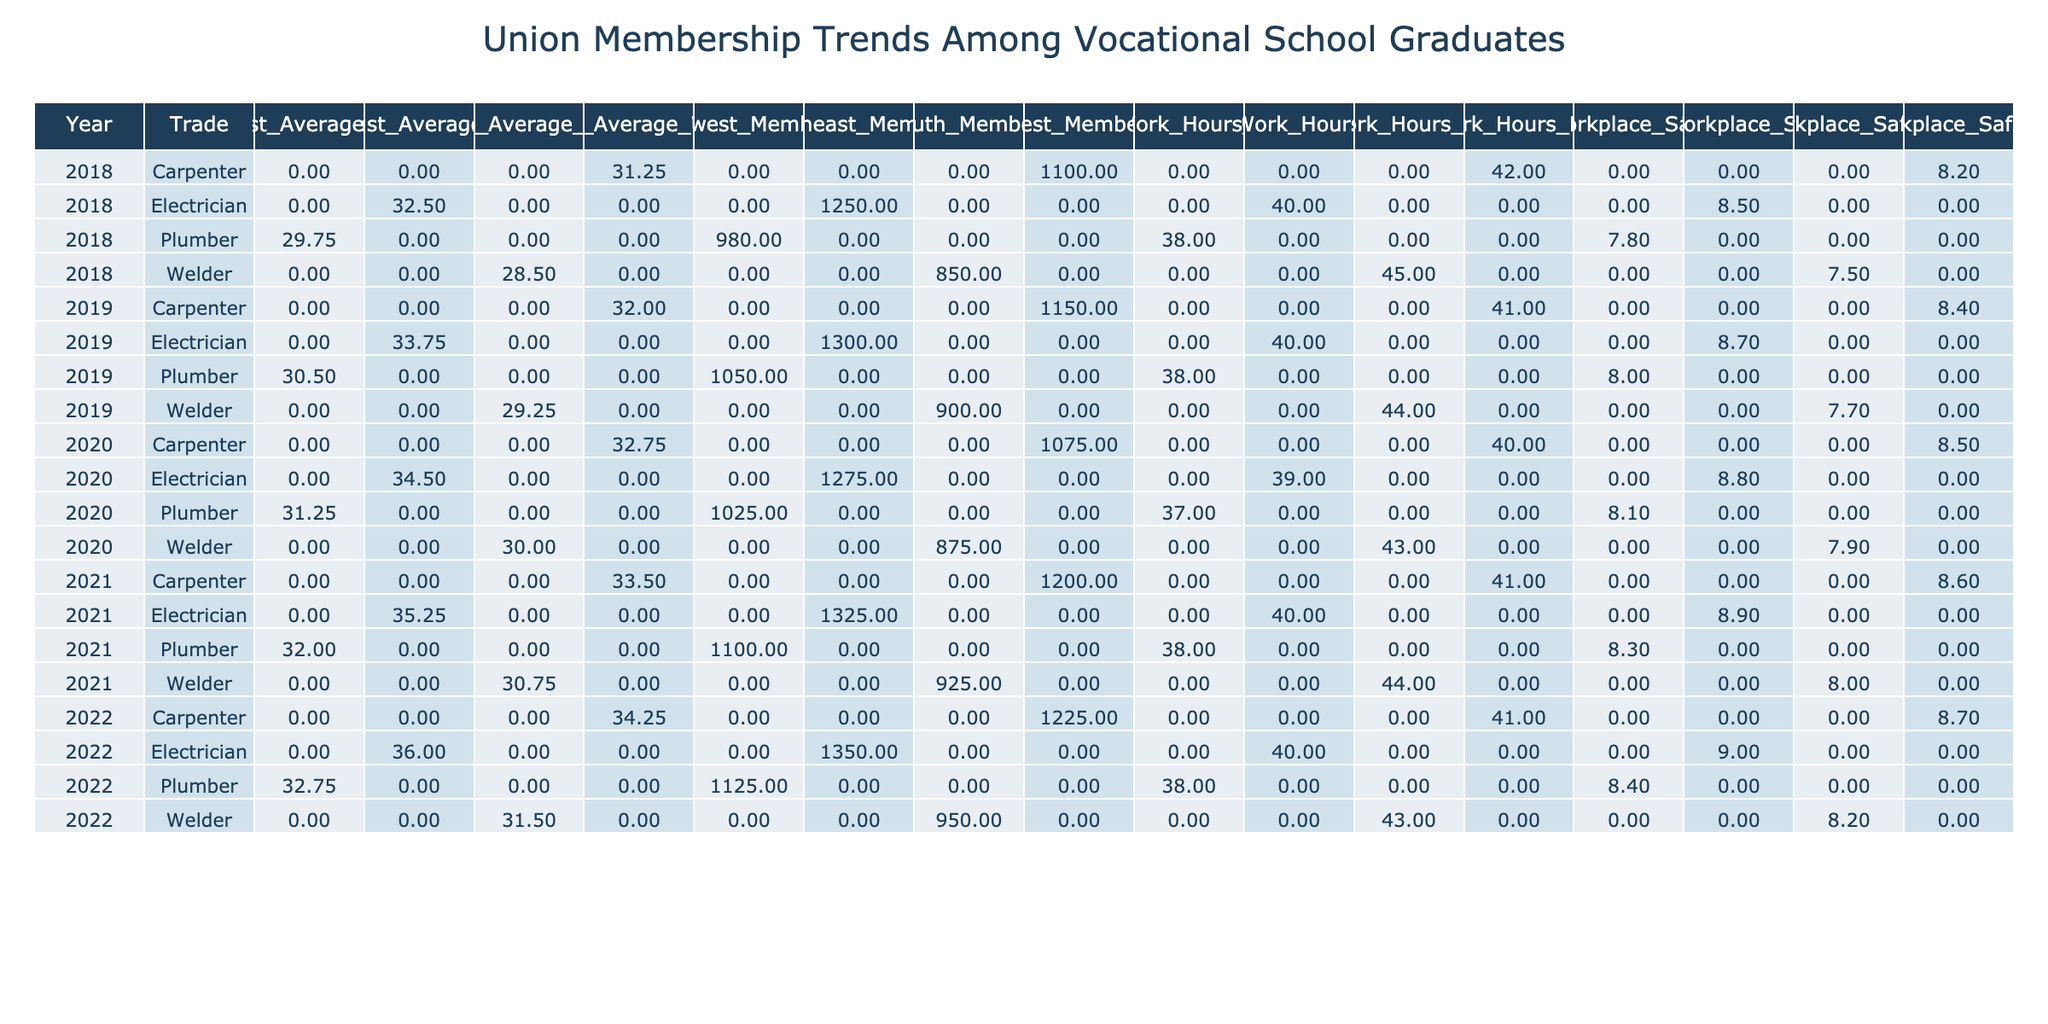What was the total number of union members for electricians in 2021? In 2021, the number of union members for electricians is listed as 1325. Thus, the total number is 1325.
Answer: 1325 What is the average wage for plumbers in the Midwest in 2020? In 2020, the average wage for plumbers in the Midwest is indicated in the table as 31.25. Thus, the average wage is 31.25.
Answer: 31.25 How many total work hours per week did welders in the South work on average from 2018 to 2022? The average work hours per week for welders from 2018 to 2022 can be calculated as follows: (45 + 44 + 43 + 44 + 43) / 5 = 43.8. Thus, the average is 43.8 hours per week.
Answer: 43.8 Did the average workplace safety rating for carpenters in the West improve from 2018 to 2022? In 2018, the safety rating for carpenters in the West was 8.2, and in 2022 it was 8.7. Since 8.7 is greater than 8.2, the average rating did improve.
Answer: Yes What trade had the highest membership count in 2019? From the data for 2019, electricians had 1300 members, plumbers had 1050, carpenters had 1150, and welders had 900. Since 1300 is the highest among these numbers, electricians had the highest membership count.
Answer: Electrician What is the percentage increase in average wage for electricians in the Northeast from 2018 to 2022? The average wage for electricians in 2018 was 32.50, and it increased to 36.00 in 2022. The percentage increase is calculated as ((36.00 - 32.50) / 32.50) * 100 = 7.69%. Thus, the percentage increase is approximately 7.69%.
Answer: 7.69% What was the average number of members for plumbers across all regions from 2018 to 2022? The total members over the years for plumbers are 980, 1050, 1025, 1100, and 1125. Summing these gives 5280, and dividing by 5 (the number of data points) yields an average of 1056. Thus, the average number of members is 1056.
Answer: 1056 Was the average wage for welders in 2021 greater than the average wage in 2020? For welders, the average wage in 2020 was 30.00 and in 2021 it was 30.75. Since 30.75 is greater than 30.00, the average wage did increase.
Answer: Yes Which region had the lowest workplace safety rating among electricians in 2019? The table shows that all regions had safety ratings of 8.7 (Northeast), 8.0 (Midwest), 8.4 (West), and 7.7 (South). The South had the lowest rating of 7.7.
Answer: South 